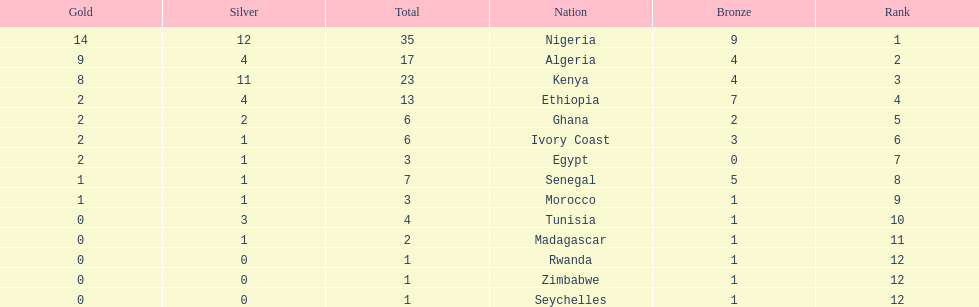The country that won the most medals was? Nigeria. 